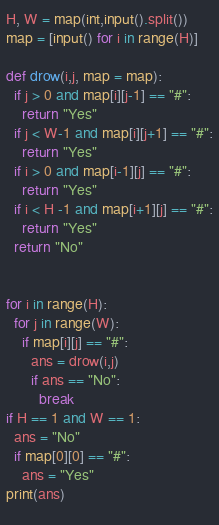<code> <loc_0><loc_0><loc_500><loc_500><_Python_>H, W = map(int,input().split())
map = [input() for i in range(H)]

def drow(i,j, map = map):
  if j > 0 and map[i][j-1] == "#":
    return "Yes"
  if j < W-1 and map[i][j+1] == "#":
    return "Yes"
  if i > 0 and map[i-1][j] == "#":
    return "Yes"
  if i < H -1 and map[i+1][j] == "#":
    return "Yes"
  return "No"


for i in range(H):
  for j in range(W):
    if map[i][j] == "#":
      ans = drow(i,j)
      if ans == "No":
        break
if H == 1 and W == 1:
  ans = "No"
  if map[0][0] == "#":
    ans = "Yes"
print(ans)
    </code> 